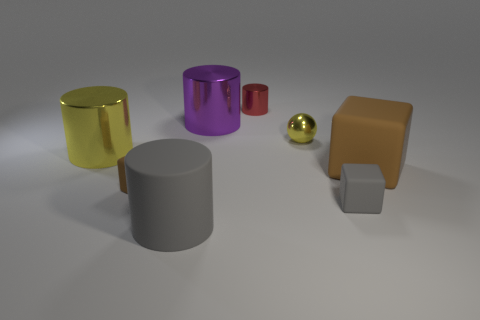Subtract all yellow cylinders. How many cylinders are left? 3 Subtract all green cylinders. Subtract all cyan balls. How many cylinders are left? 4 Subtract all blocks. How many objects are left? 5 Add 8 large yellow objects. How many large yellow objects are left? 9 Add 5 shiny things. How many shiny things exist? 9 Subtract 0 green spheres. How many objects are left? 8 Subtract all large yellow cylinders. Subtract all purple things. How many objects are left? 6 